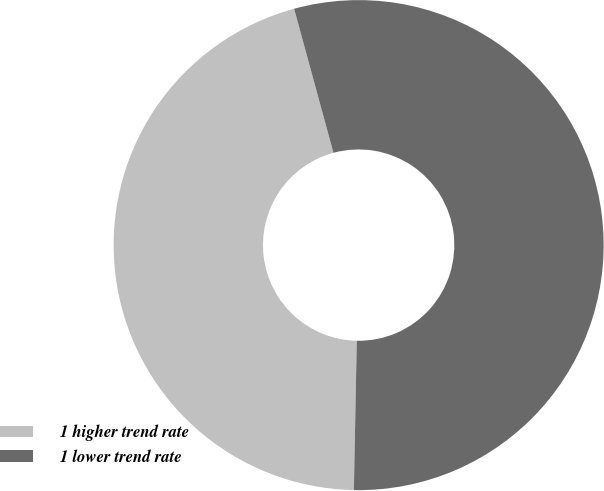<chart> <loc_0><loc_0><loc_500><loc_500><pie_chart><fcel>1 higher trend rate<fcel>1 lower trend rate<nl><fcel>45.45%<fcel>54.55%<nl></chart> 